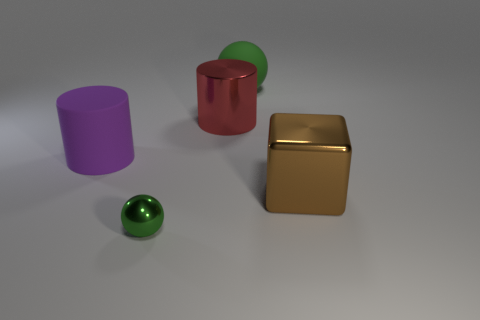Compare the sizes of the objects; which one appears to be the largest and the smallest? The purple cylinder on the left seems to be the largest object due to its height and diameter. The smallest object is the green sphere in front, which appears significantly smaller in size compared to the other objects. Could you suggest what these objects might symbolize or represent? While the objects in the image are simple geometric shapes, one could interpret the variety of colors and finishes as a representation of diversity in unity. The sphere might symbolize completeness or infinity, the cube could represent stability and permanence, and the cylinders may imply functionality or storage. 